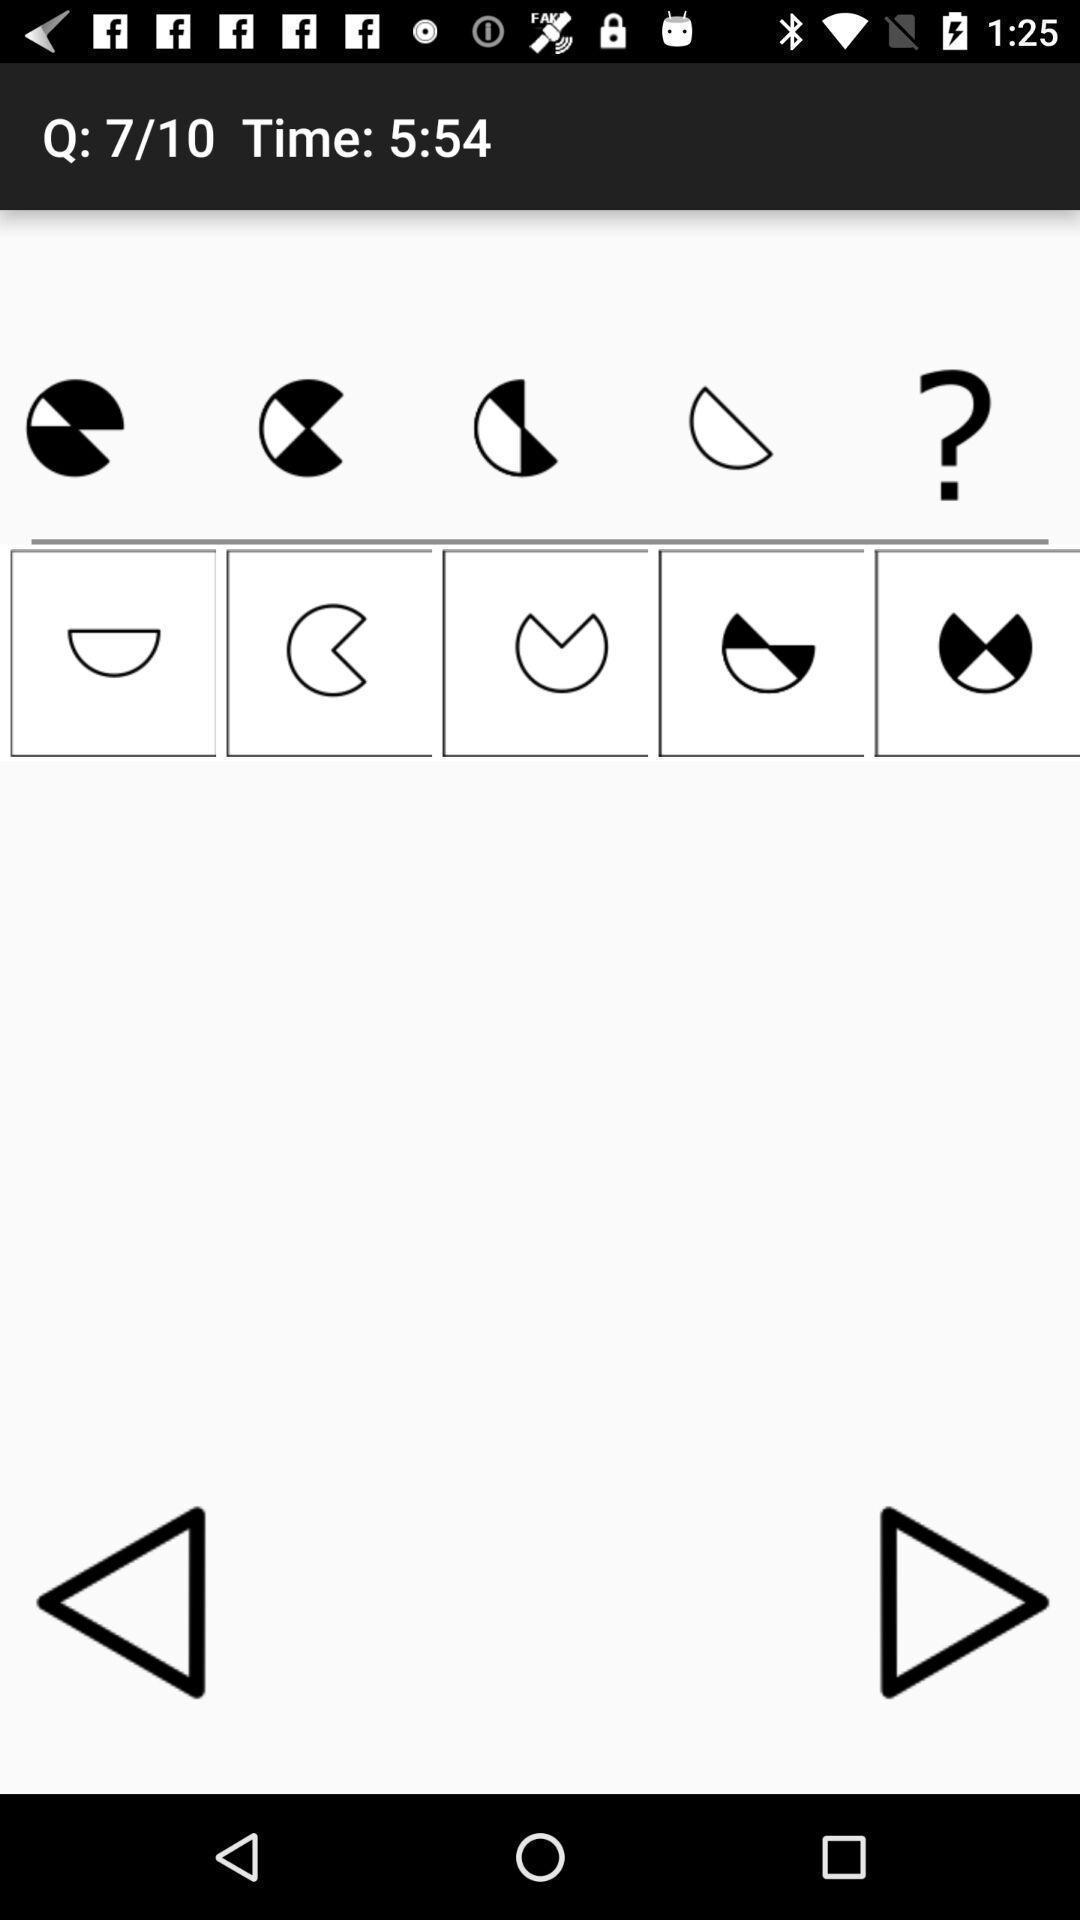Describe this image in words. Screen showing symbols. 